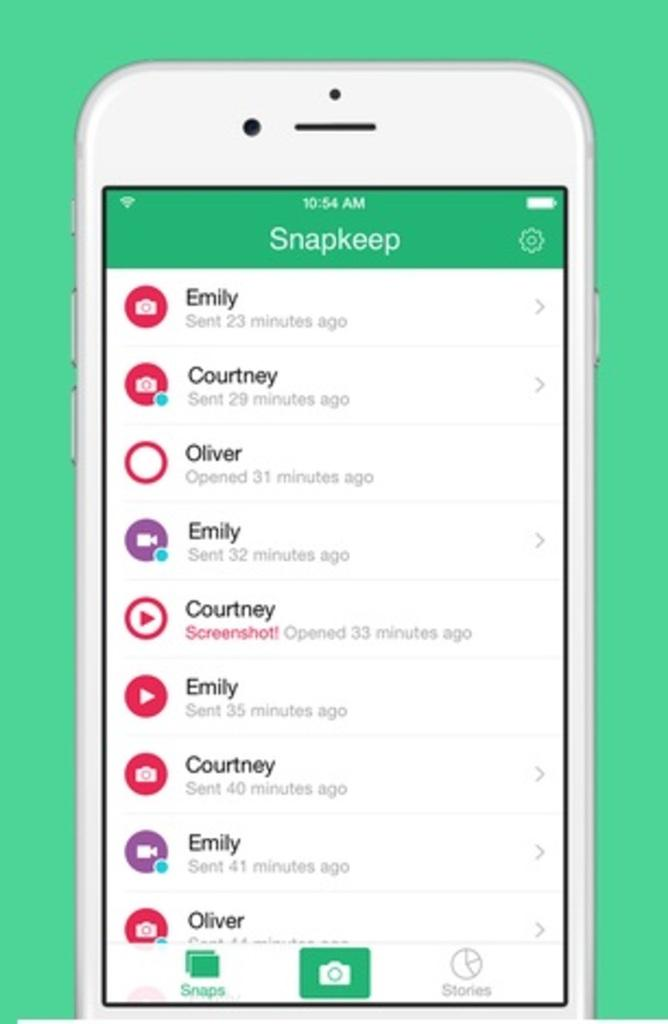<image>
Give a short and clear explanation of the subsequent image. A phone running an app called Snapkeep on a green background 